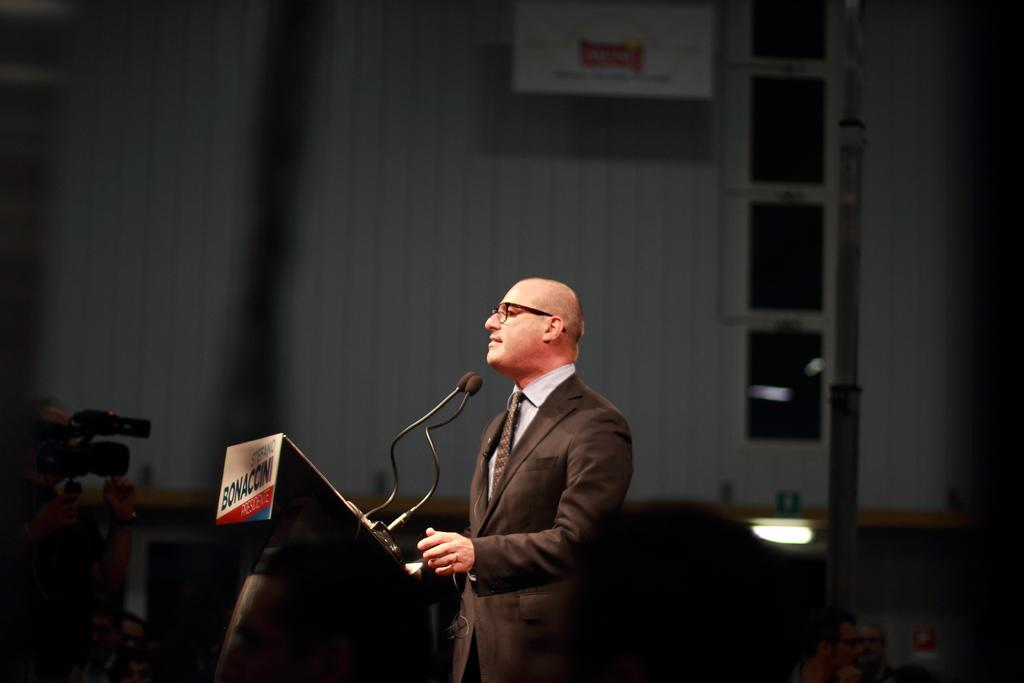What is the main subject of the image? There is a person standing in the image. What is the person wearing? The person is wearing a blazer. Where is the person located in the image? The person is at the bottom of the image. What object is on the left side of the person? There is a microphone (Mic) on the left side of the person. What can be seen in the background of the image? There is a wall in the background of the image. How many cherries are on the hall in the image? There are no cherries or halls present in the image. What type of straw is being used by the person in the image? There is no straw visible in the image. 